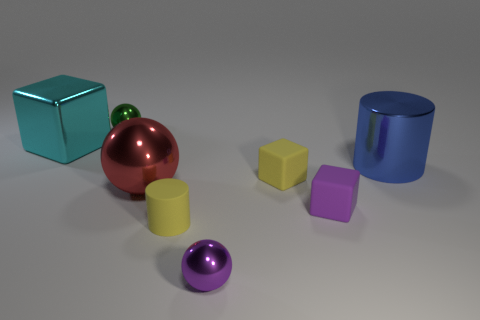There is a large red metal sphere; what number of green shiny spheres are right of it? Upon examining the scene, one can see that there are no shiny green spheres positioned to the right of the large red metal sphere. 